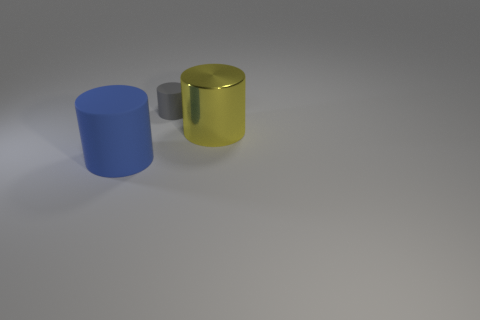Are there any big metallic things that have the same color as the large metallic cylinder?
Provide a short and direct response. No. The big metallic thing is what color?
Provide a succinct answer. Yellow. What color is the other cylinder that is the same material as the big blue cylinder?
Give a very brief answer. Gray. Is the color of the large rubber cylinder the same as the large cylinder right of the tiny matte cylinder?
Your answer should be compact. No. There is a small gray matte object; what number of big blue things are behind it?
Provide a succinct answer. 0. How many objects are either brown spheres or big cylinders that are on the left side of the gray thing?
Your answer should be very brief. 1. Is there a metallic cylinder that is in front of the rubber thing in front of the large yellow cylinder?
Your response must be concise. No. There is a rubber cylinder on the right side of the blue cylinder; what is its color?
Keep it short and to the point. Gray. Are there the same number of large yellow metal cylinders in front of the large yellow metallic cylinder and purple rubber cylinders?
Offer a very short reply. Yes. There is a object that is both behind the large blue object and on the left side of the big shiny cylinder; what is its shape?
Keep it short and to the point. Cylinder. 